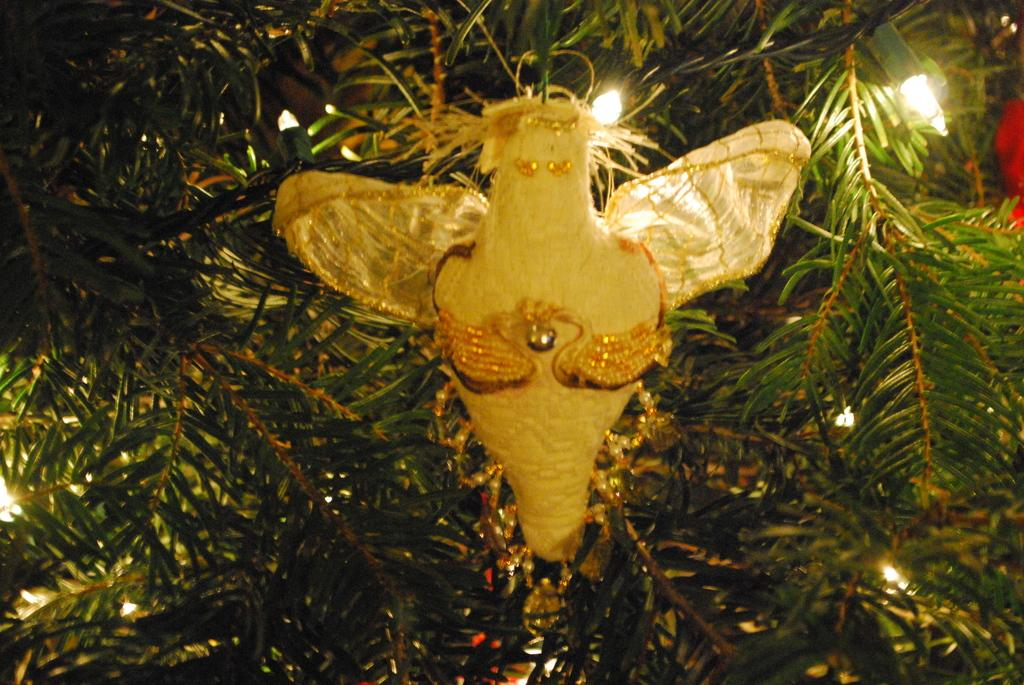What is the main subject in the center of the image? There is a decoration in the center of the image. What can be seen in the background of the image? There are leaves and lights in the background of the image. What type of voice can be heard coming from the decoration in the image? There is no voice present in the image, as it is a decoration and not a source of sound. 